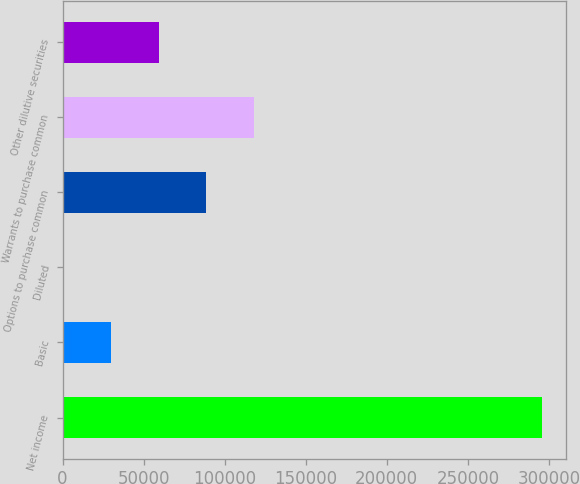Convert chart. <chart><loc_0><loc_0><loc_500><loc_500><bar_chart><fcel>Net income<fcel>Basic<fcel>Diluted<fcel>Options to purchase common<fcel>Warrants to purchase common<fcel>Other dilutive securities<nl><fcel>295864<fcel>29587.2<fcel>0.94<fcel>88759.9<fcel>118346<fcel>59173.6<nl></chart> 